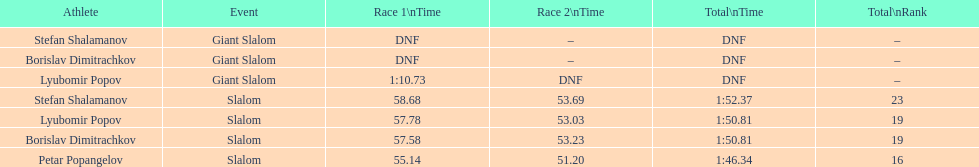Which athlete finished the first race but did not finish the second race? Lyubomir Popov. 